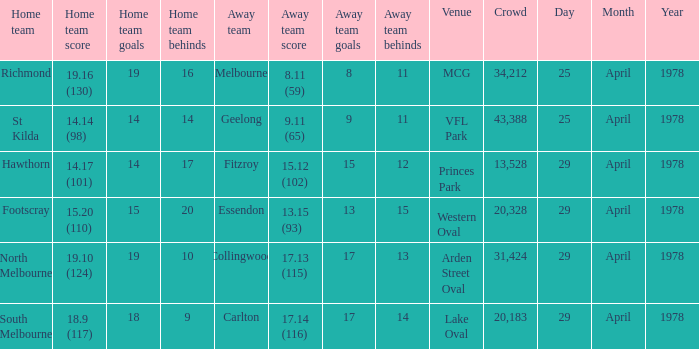What was the away team that played at Princes Park? Fitzroy. 